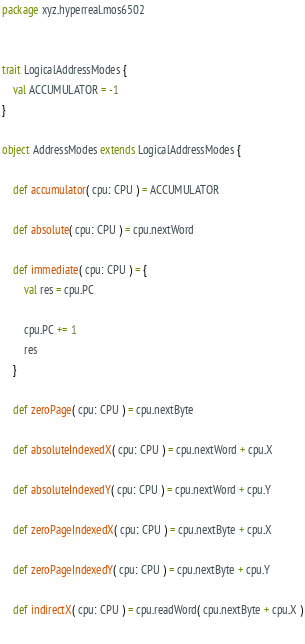<code> <loc_0><loc_0><loc_500><loc_500><_Scala_>package xyz.hyperreal.mos6502


trait LogicalAddressModes {
	val ACCUMULATOR = -1
}

object AddressModes extends LogicalAddressModes {
	
	def accumulator( cpu: CPU ) = ACCUMULATOR
	
	def absolute( cpu: CPU ) = cpu.nextWord
	
	def immediate( cpu: CPU ) = {
		val res = cpu.PC
		
		cpu.PC += 1
		res
	}
	
	def zeroPage( cpu: CPU ) = cpu.nextByte
	
	def absoluteIndexedX( cpu: CPU ) = cpu.nextWord + cpu.X
	
	def absoluteIndexedY( cpu: CPU ) = cpu.nextWord + cpu.Y
	
	def zeroPageIndexedX( cpu: CPU ) = cpu.nextByte + cpu.X
	
	def zeroPageIndexedY( cpu: CPU ) = cpu.nextByte + cpu.Y
	
	def indirectX( cpu: CPU ) = cpu.readWord( cpu.nextByte + cpu.X )
	</code> 